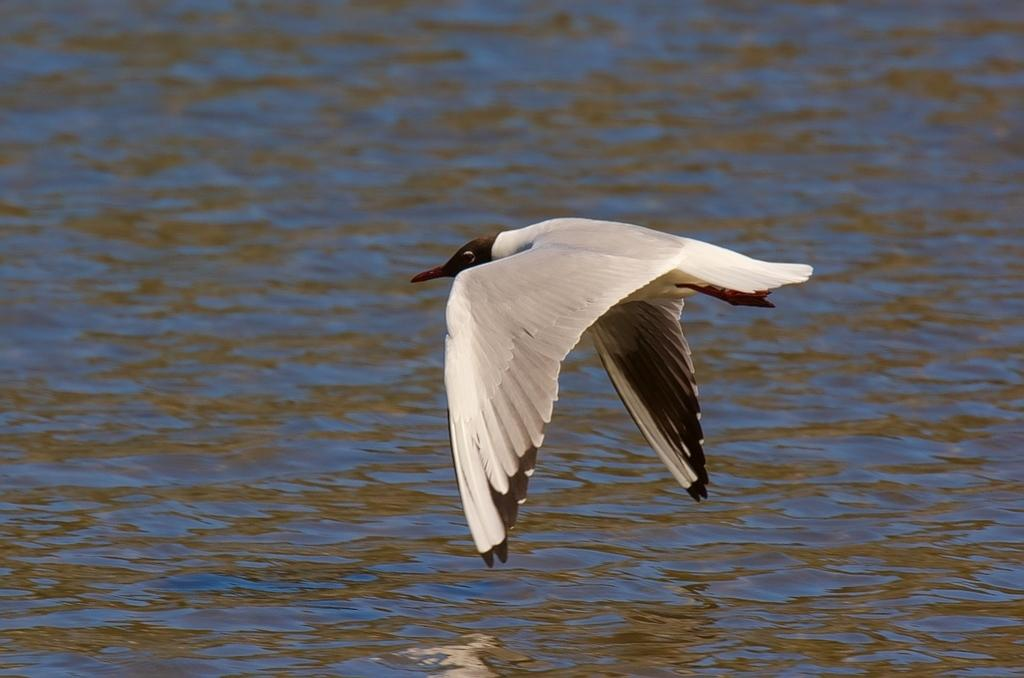What type of animal can be seen in the image? There is a bird in the image. What is the bird doing in the image? The bird is flying in the air. What can be seen in the background of the image? The background of the image includes water. What scientific theory is being discussed by the bird in the image? There is no indication in the image that the bird is discussing any scientific theory. 